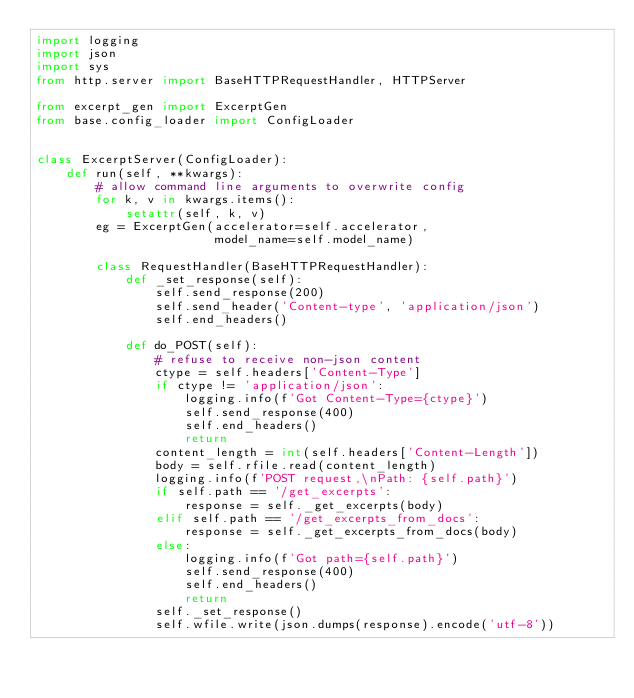Convert code to text. <code><loc_0><loc_0><loc_500><loc_500><_Python_>import logging
import json
import sys
from http.server import BaseHTTPRequestHandler, HTTPServer

from excerpt_gen import ExcerptGen
from base.config_loader import ConfigLoader


class ExcerptServer(ConfigLoader):
    def run(self, **kwargs):
        # allow command line arguments to overwrite config
        for k, v in kwargs.items():
            setattr(self, k, v)
        eg = ExcerptGen(accelerator=self.accelerator,
                        model_name=self.model_name)

        class RequestHandler(BaseHTTPRequestHandler):
            def _set_response(self):
                self.send_response(200)
                self.send_header('Content-type', 'application/json')
                self.end_headers()

            def do_POST(self):
                # refuse to receive non-json content
                ctype = self.headers['Content-Type']
                if ctype != 'application/json':
                    logging.info(f'Got Content-Type={ctype}')
                    self.send_response(400)
                    self.end_headers()
                    return
                content_length = int(self.headers['Content-Length'])
                body = self.rfile.read(content_length)
                logging.info(f'POST request,\nPath: {self.path}')
                if self.path == '/get_excerpts':
                    response = self._get_excerpts(body)
                elif self.path == '/get_excerpts_from_docs':
                    response = self._get_excerpts_from_docs(body)
                else:
                    logging.info(f'Got path={self.path}')
                    self.send_response(400)
                    self.end_headers()
                    return
                self._set_response()
                self.wfile.write(json.dumps(response).encode('utf-8'))
</code> 